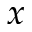Convert formula to latex. <formula><loc_0><loc_0><loc_500><loc_500>x</formula> 